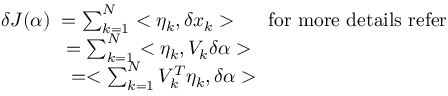Convert formula to latex. <formula><loc_0><loc_0><loc_500><loc_500>\begin{array} { l } { \delta J ( \alpha ) \, = \sum _ { k = 1 } ^ { N } < \eta _ { k } , \delta x _ { k } > \, f o r m o r e d e t a i l s r e f e r } \\ { \, = \sum _ { k = 1 } ^ { N } < \eta _ { k } , V _ { k } \delta \alpha > } \\ { \, = < \sum _ { k = 1 } ^ { N } V _ { k } ^ { T } \eta _ { k } , \delta \alpha > } \end{array}</formula> 